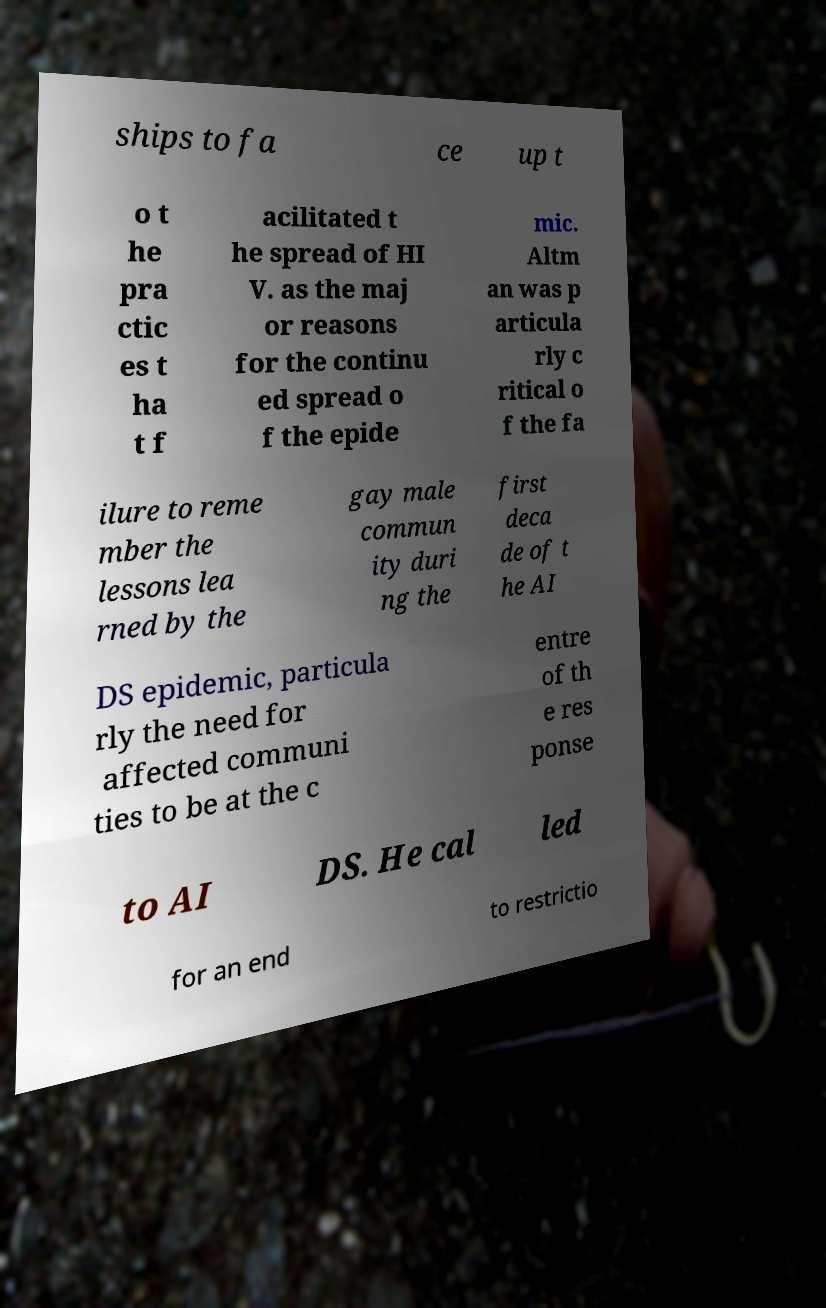Could you assist in decoding the text presented in this image and type it out clearly? ships to fa ce up t o t he pra ctic es t ha t f acilitated t he spread of HI V. as the maj or reasons for the continu ed spread o f the epide mic. Altm an was p articula rly c ritical o f the fa ilure to reme mber the lessons lea rned by the gay male commun ity duri ng the first deca de of t he AI DS epidemic, particula rly the need for affected communi ties to be at the c entre of th e res ponse to AI DS. He cal led for an end to restrictio 